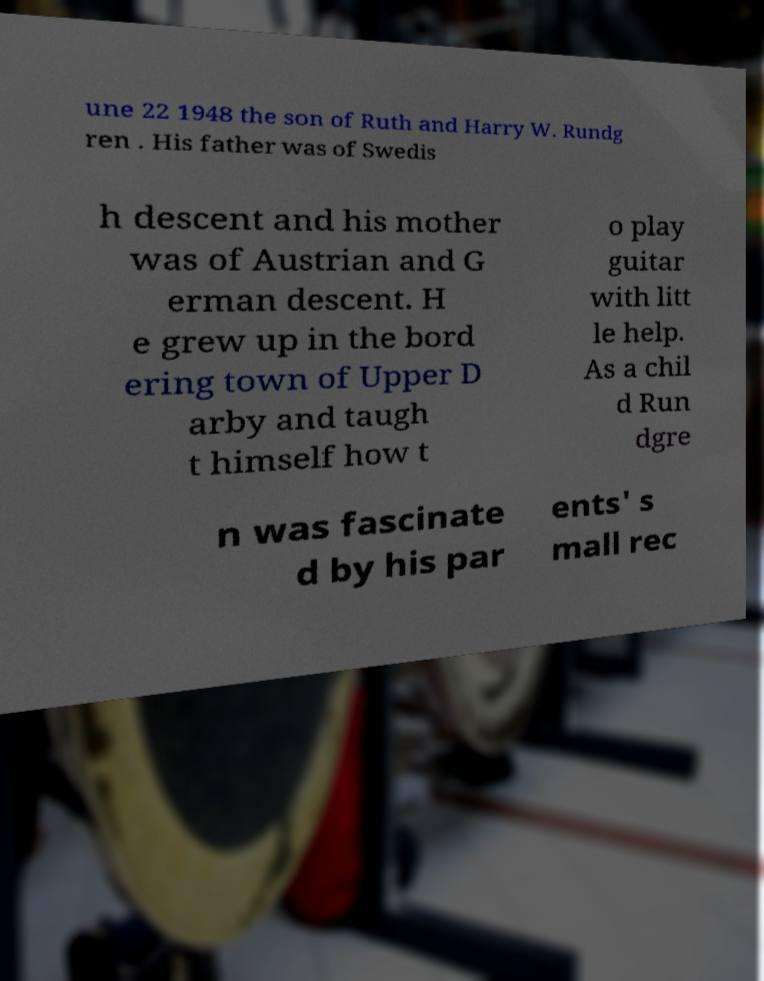Can you read and provide the text displayed in the image?This photo seems to have some interesting text. Can you extract and type it out for me? une 22 1948 the son of Ruth and Harry W. Rundg ren . His father was of Swedis h descent and his mother was of Austrian and G erman descent. H e grew up in the bord ering town of Upper D arby and taugh t himself how t o play guitar with litt le help. As a chil d Run dgre n was fascinate d by his par ents' s mall rec 